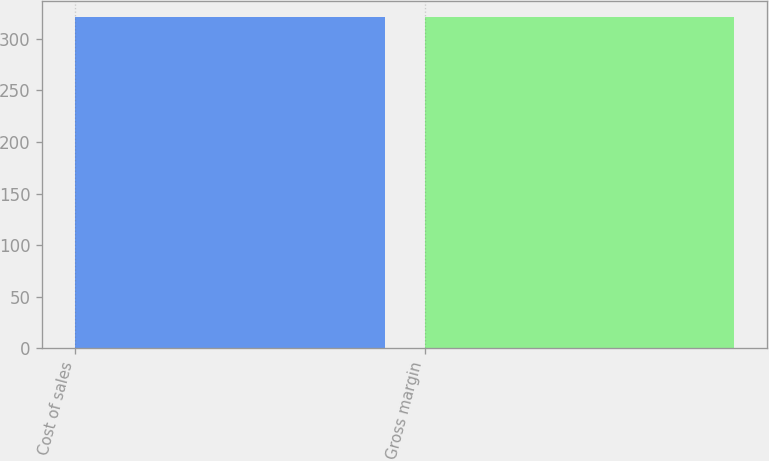Convert chart. <chart><loc_0><loc_0><loc_500><loc_500><bar_chart><fcel>Cost of sales<fcel>Gross margin<nl><fcel>321<fcel>321.1<nl></chart> 